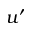<formula> <loc_0><loc_0><loc_500><loc_500>u ^ { \prime }</formula> 